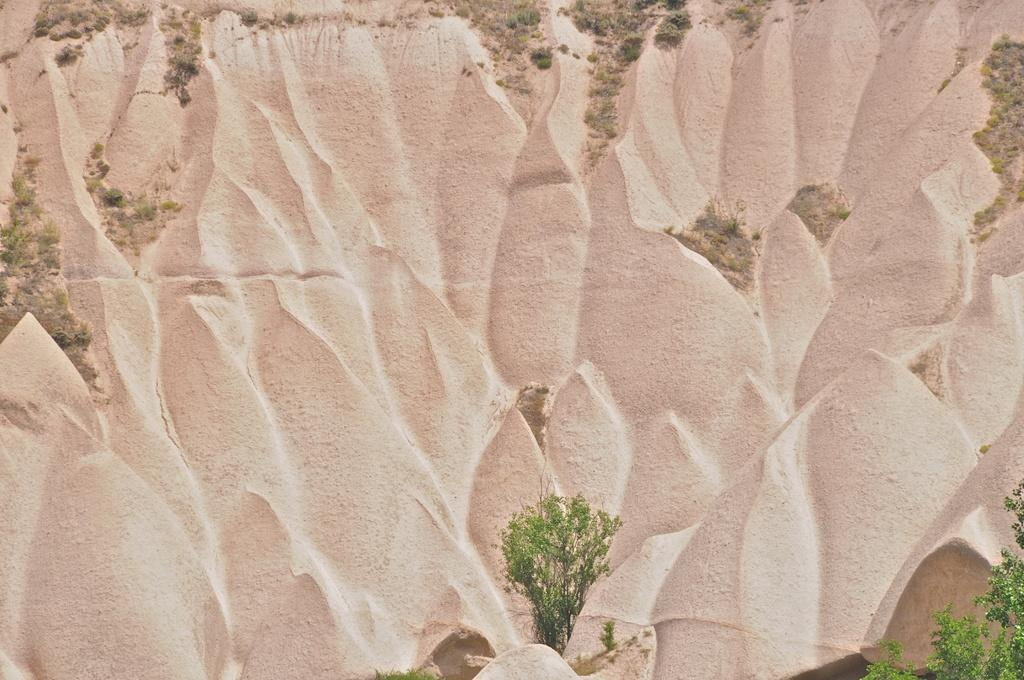What type of living organisms can be seen in the image? Plants can be seen in the image. What can be found on the wall in the image? There is carving on the wall in the image. What type of feather can be seen floating in the air in the image? There is no feather present in the image; it only features plants and carving on the wall. 